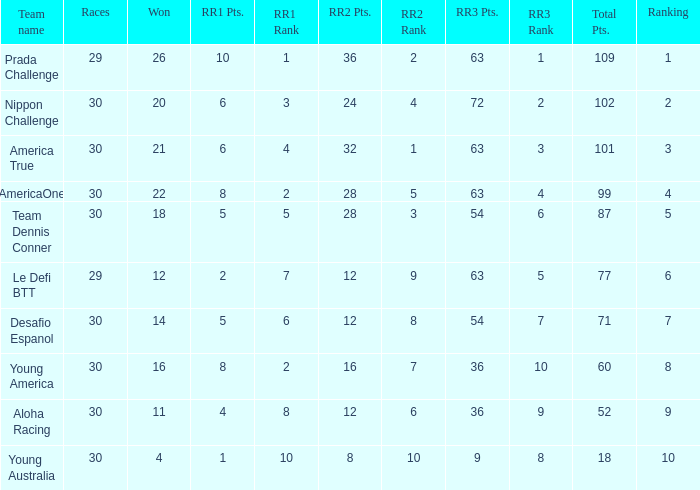Name the most rr1 pts for 7 ranking 5.0. 